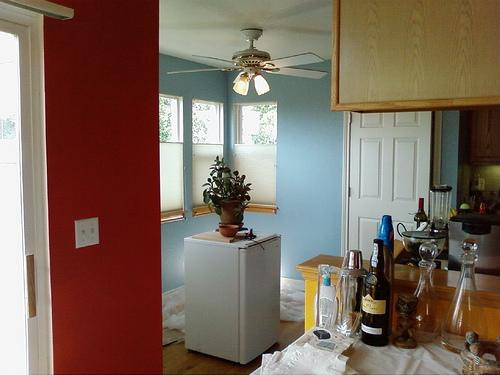What is sitting on the mini fridge in the center of the room? Please explain your reasoning. potted plant. A small plant in a pot is on top of a small white appliance in a home. 